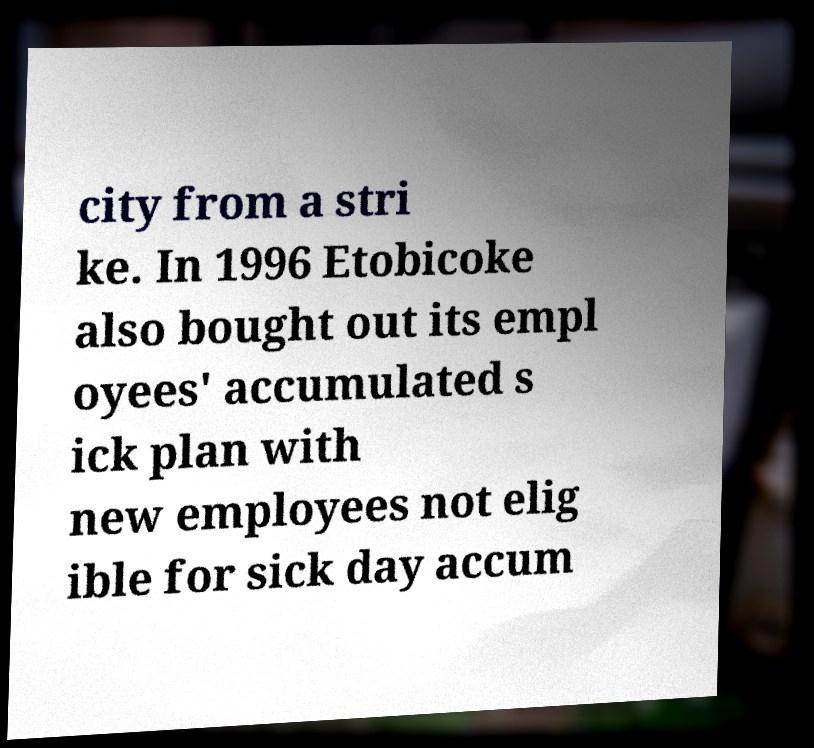Can you read and provide the text displayed in the image?This photo seems to have some interesting text. Can you extract and type it out for me? city from a stri ke. In 1996 Etobicoke also bought out its empl oyees' accumulated s ick plan with new employees not elig ible for sick day accum 